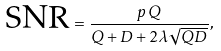<formula> <loc_0><loc_0><loc_500><loc_500>\text {SNR} = \frac { p \, Q } { Q + D + 2 \lambda \sqrt { Q D } } ,</formula> 